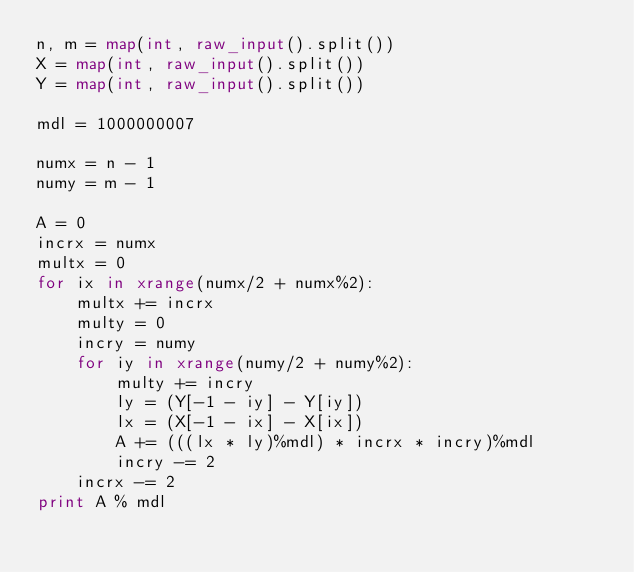<code> <loc_0><loc_0><loc_500><loc_500><_Python_>n, m = map(int, raw_input().split())
X = map(int, raw_input().split())
Y = map(int, raw_input().split())

mdl = 1000000007

numx = n - 1
numy = m - 1

A = 0
incrx = numx
multx = 0
for ix in xrange(numx/2 + numx%2):
    multx += incrx
    multy = 0
    incry = numy
    for iy in xrange(numy/2 + numy%2):
        multy += incry
        ly = (Y[-1 - iy] - Y[iy])
        lx = (X[-1 - ix] - X[ix])
        A += (((lx * ly)%mdl) * incrx * incry)%mdl
        incry -= 2
    incrx -= 2
print A % mdl</code> 